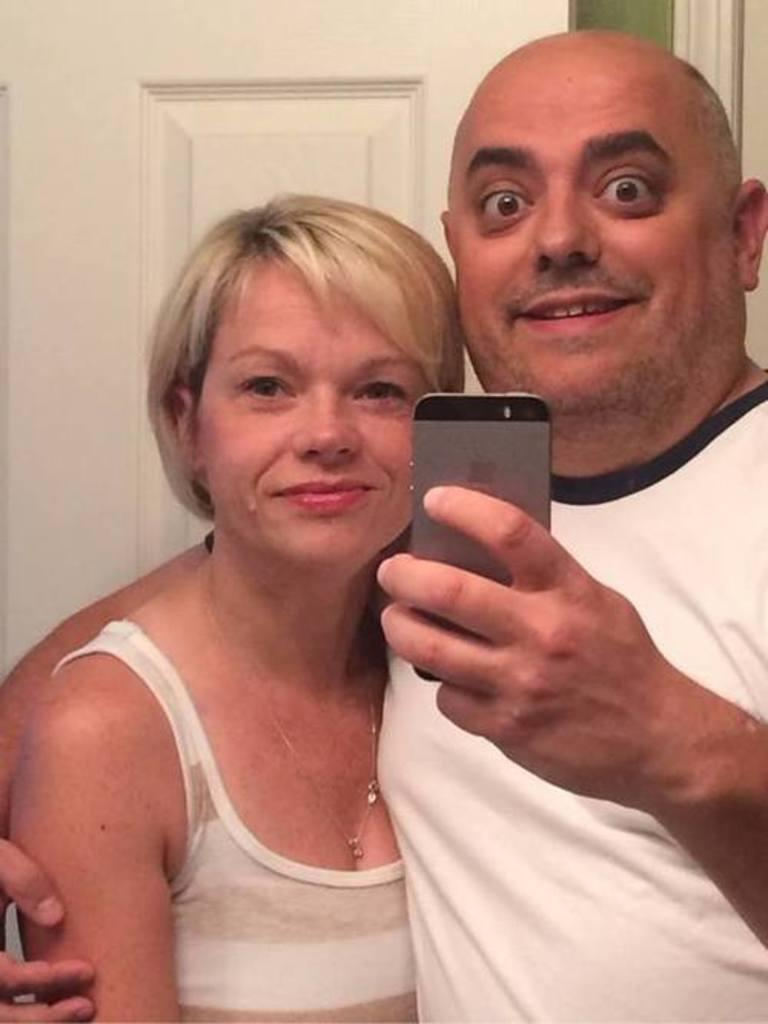How many people are in the image? There are two people in the image. What are the two people doing in the image? The two people are standing and taking a selfie. What device is being used to take the selfie? A mobile phone is being used to take the selfie. What type of cork can be seen in the image? There is no cork present in the image. Are the two people standing on a sidewalk in the image? The location of the two people is not specified in the image, so we cannot determine if they are standing on a sidewalk. 